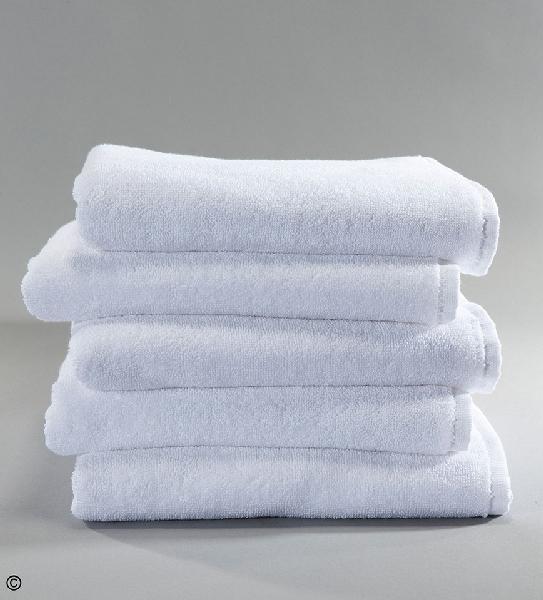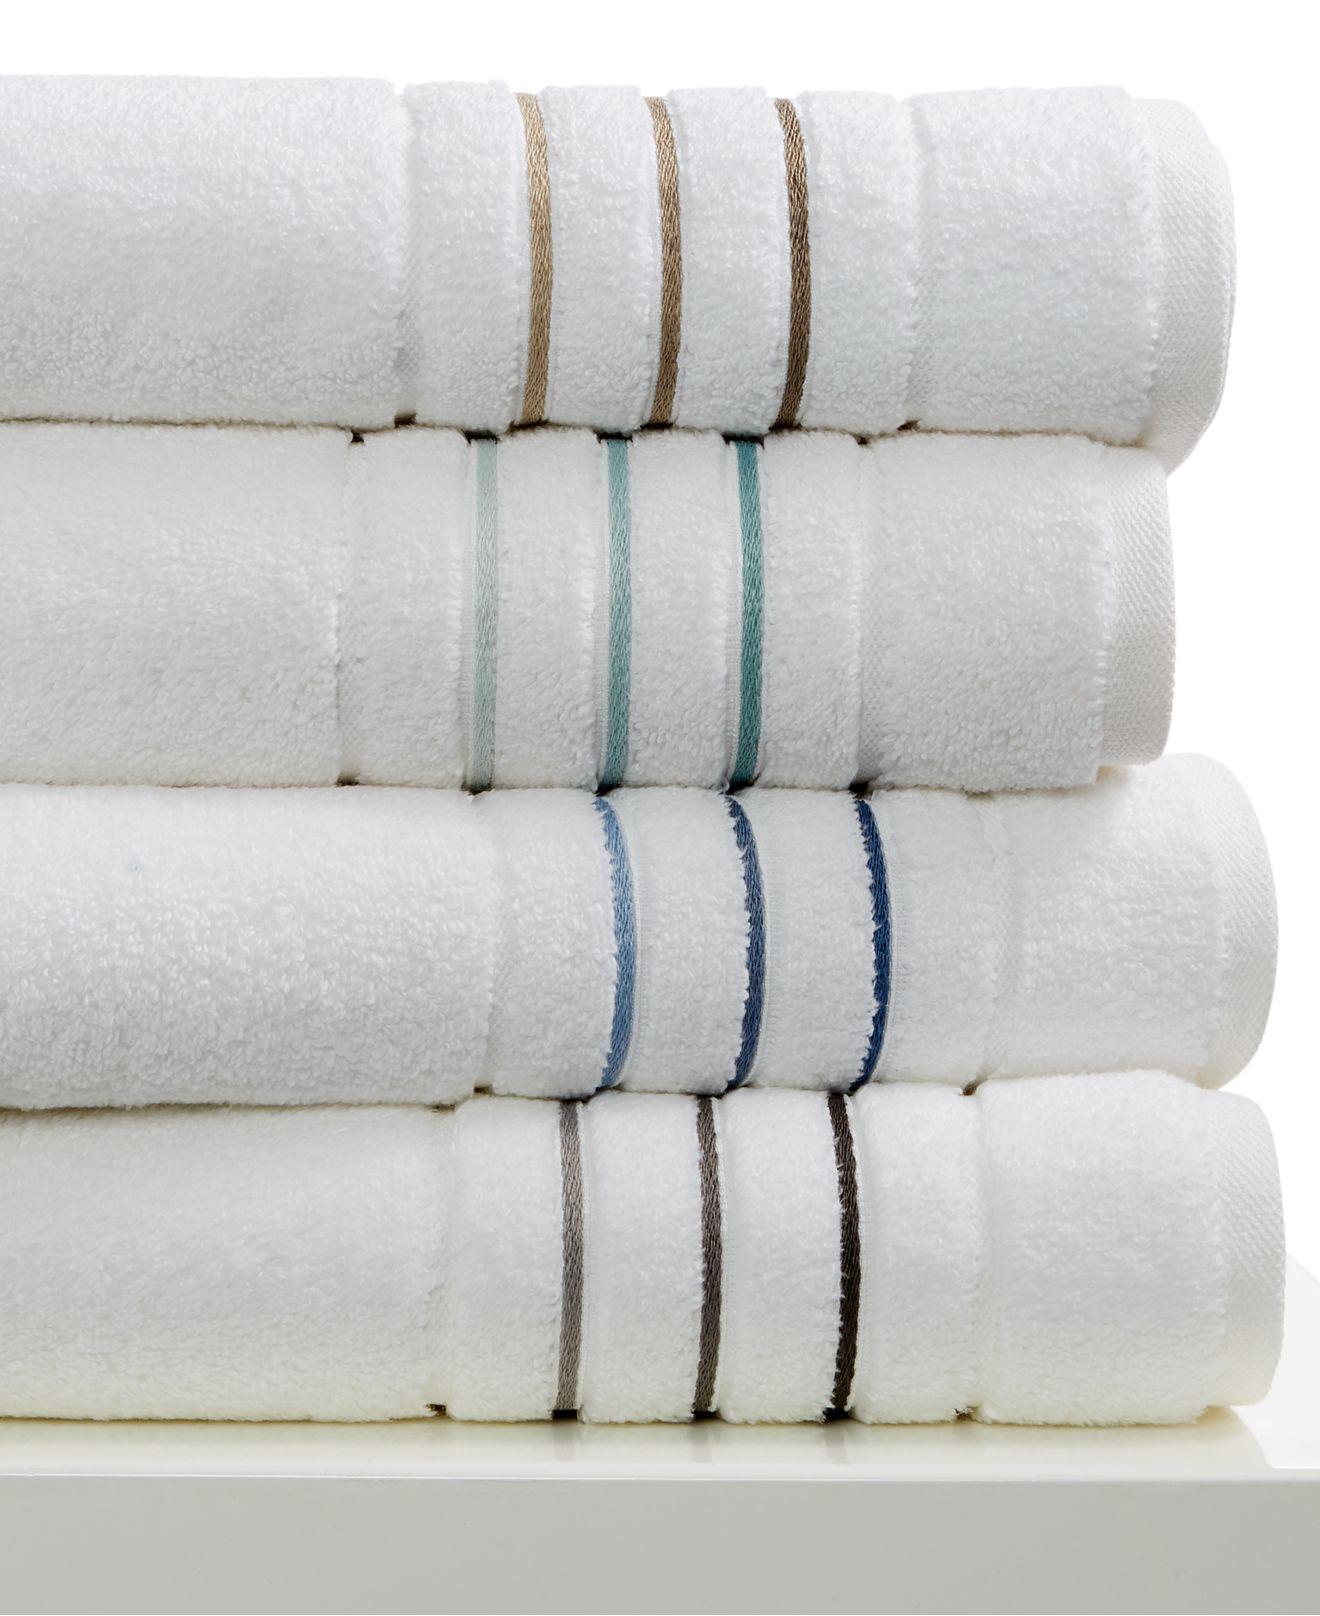The first image is the image on the left, the second image is the image on the right. For the images displayed, is the sentence "A towel pile includes white towels with contrast stripe trim." factually correct? Answer yes or no. Yes. 